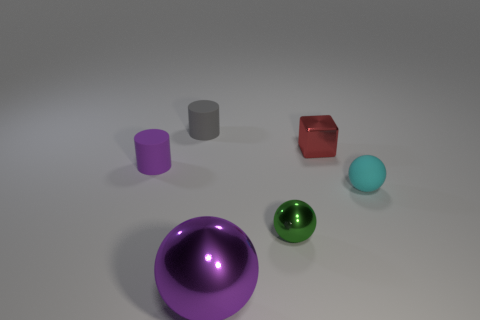Add 2 small gray spheres. How many objects exist? 8 Subtract all cylinders. How many objects are left? 4 Subtract 1 green spheres. How many objects are left? 5 Subtract all tiny cyan rubber spheres. Subtract all gray objects. How many objects are left? 4 Add 2 large purple metal balls. How many large purple metal balls are left? 3 Add 2 cylinders. How many cylinders exist? 4 